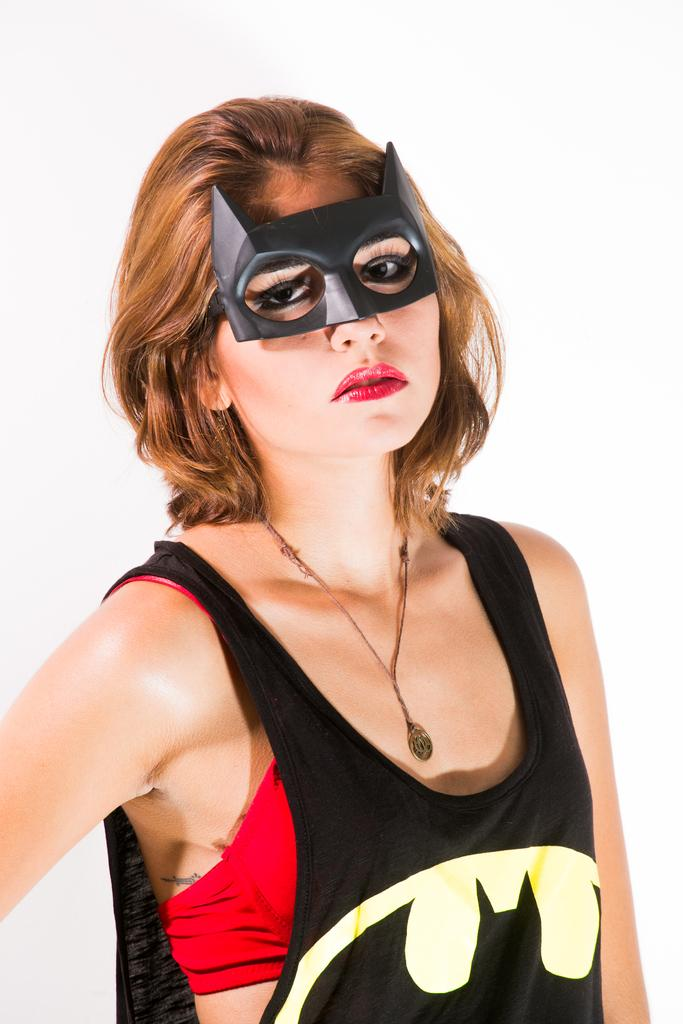Who is present in the image? There is a woman in the image. What is the woman wearing on her face? The woman is wearing a mask. What color is the background of the image? The background of the image is white. What type of stove can be seen in the image? There is no stove present in the image. Is the woman in the image a lawyer? The image does not provide any information about the woman's profession, so it cannot be determined if she is a lawyer. 